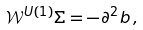Convert formula to latex. <formula><loc_0><loc_0><loc_500><loc_500>\mathcal { W } ^ { U ( 1 ) } \Sigma = - \partial ^ { 2 } b \, ,</formula> 